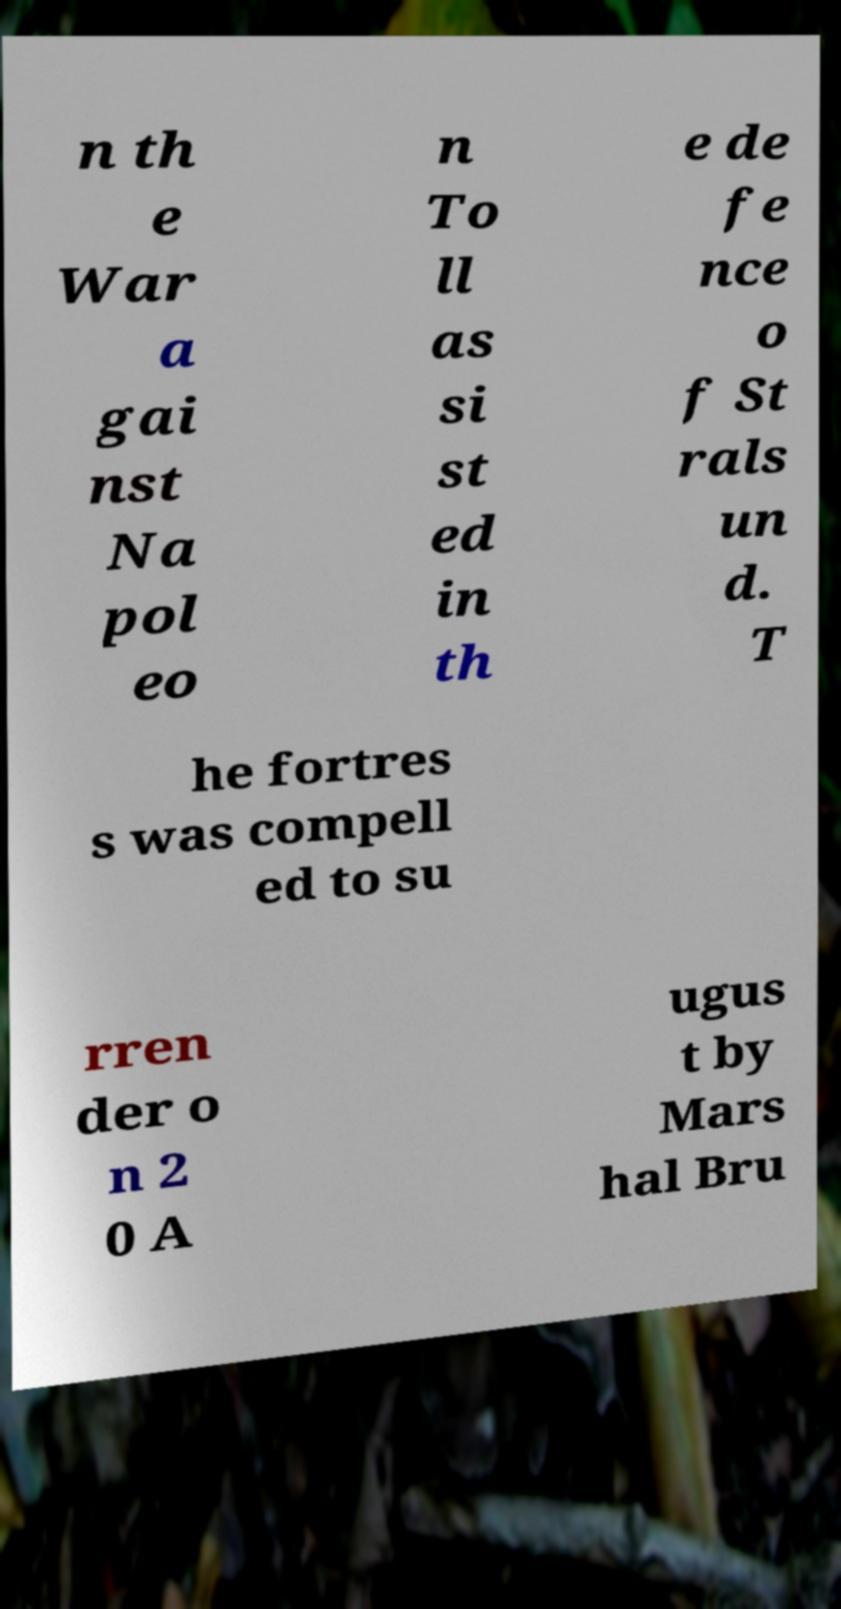For documentation purposes, I need the text within this image transcribed. Could you provide that? n th e War a gai nst Na pol eo n To ll as si st ed in th e de fe nce o f St rals un d. T he fortres s was compell ed to su rren der o n 2 0 A ugus t by Mars hal Bru 